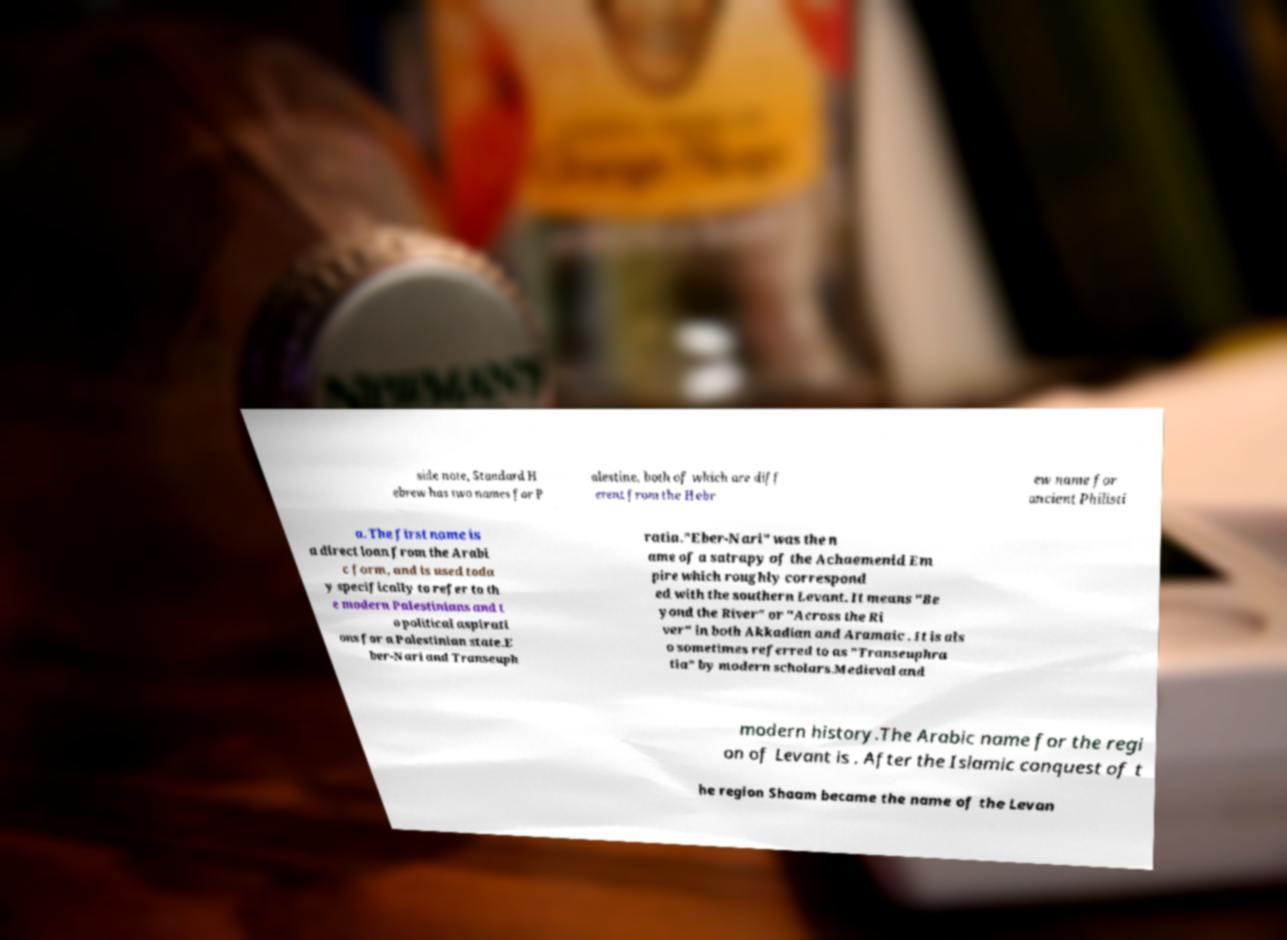I need the written content from this picture converted into text. Can you do that? side note, Standard H ebrew has two names for P alestine, both of which are diff erent from the Hebr ew name for ancient Philisti a. The first name is a direct loan from the Arabi c form, and is used toda y specifically to refer to th e modern Palestinians and t o political aspirati ons for a Palestinian state.E ber-Nari and Transeuph ratia."Eber-Nari" was the n ame of a satrapy of the Achaemenid Em pire which roughly correspond ed with the southern Levant. It means "Be yond the River" or "Across the Ri ver" in both Akkadian and Aramaic . It is als o sometimes referred to as "Transeuphra tia" by modern scholars.Medieval and modern history.The Arabic name for the regi on of Levant is . After the Islamic conquest of t he region Shaam became the name of the Levan 